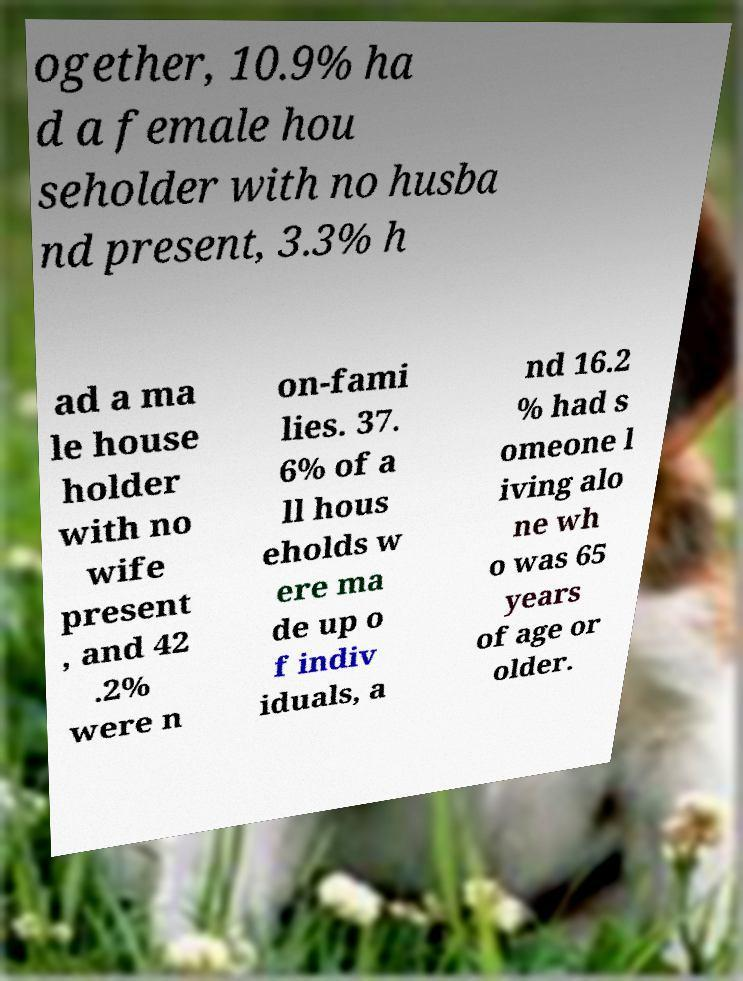For documentation purposes, I need the text within this image transcribed. Could you provide that? ogether, 10.9% ha d a female hou seholder with no husba nd present, 3.3% h ad a ma le house holder with no wife present , and 42 .2% were n on-fami lies. 37. 6% of a ll hous eholds w ere ma de up o f indiv iduals, a nd 16.2 % had s omeone l iving alo ne wh o was 65 years of age or older. 